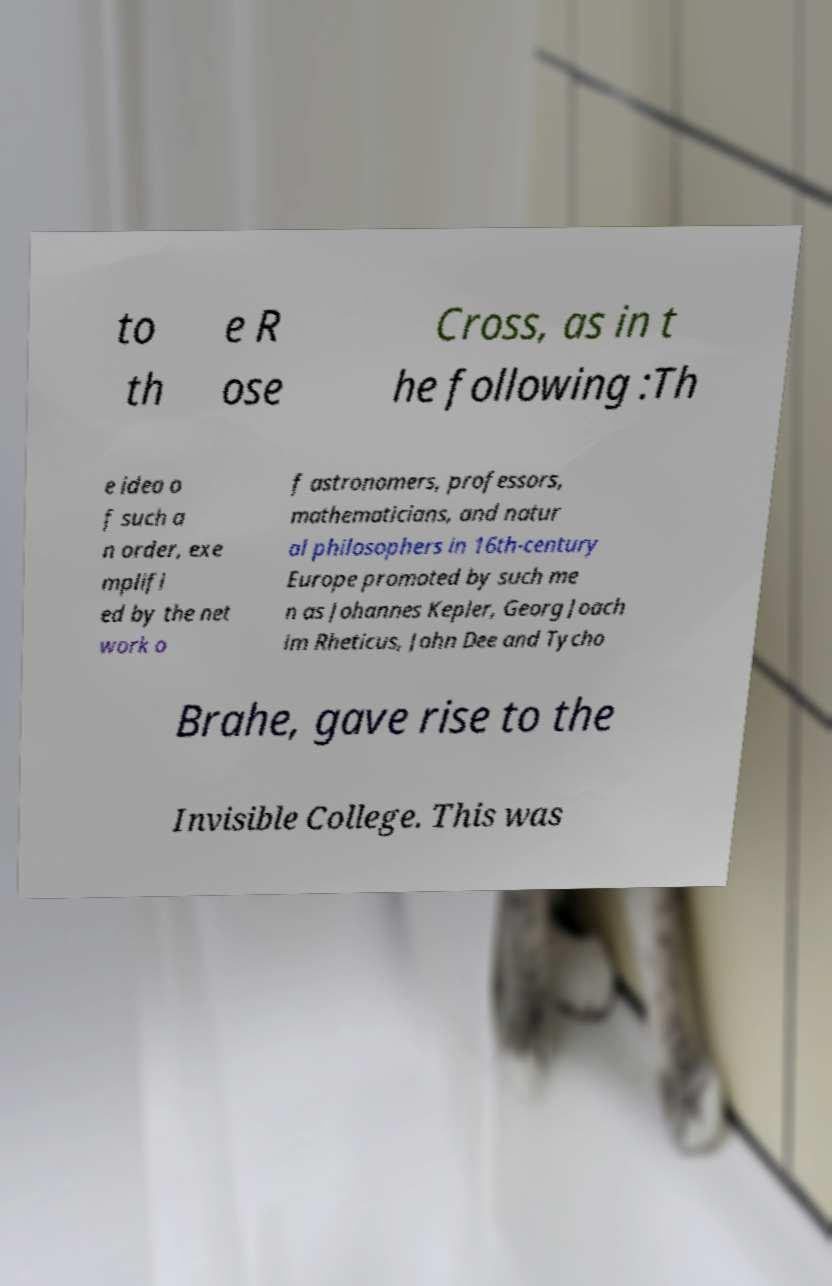Could you assist in decoding the text presented in this image and type it out clearly? to th e R ose Cross, as in t he following :Th e idea o f such a n order, exe mplifi ed by the net work o f astronomers, professors, mathematicians, and natur al philosophers in 16th-century Europe promoted by such me n as Johannes Kepler, Georg Joach im Rheticus, John Dee and Tycho Brahe, gave rise to the Invisible College. This was 